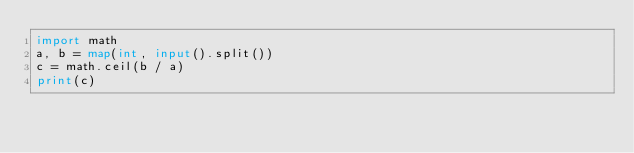Convert code to text. <code><loc_0><loc_0><loc_500><loc_500><_Python_>import math
a, b = map(int, input().split())
c = math.ceil(b / a)
print(c)</code> 